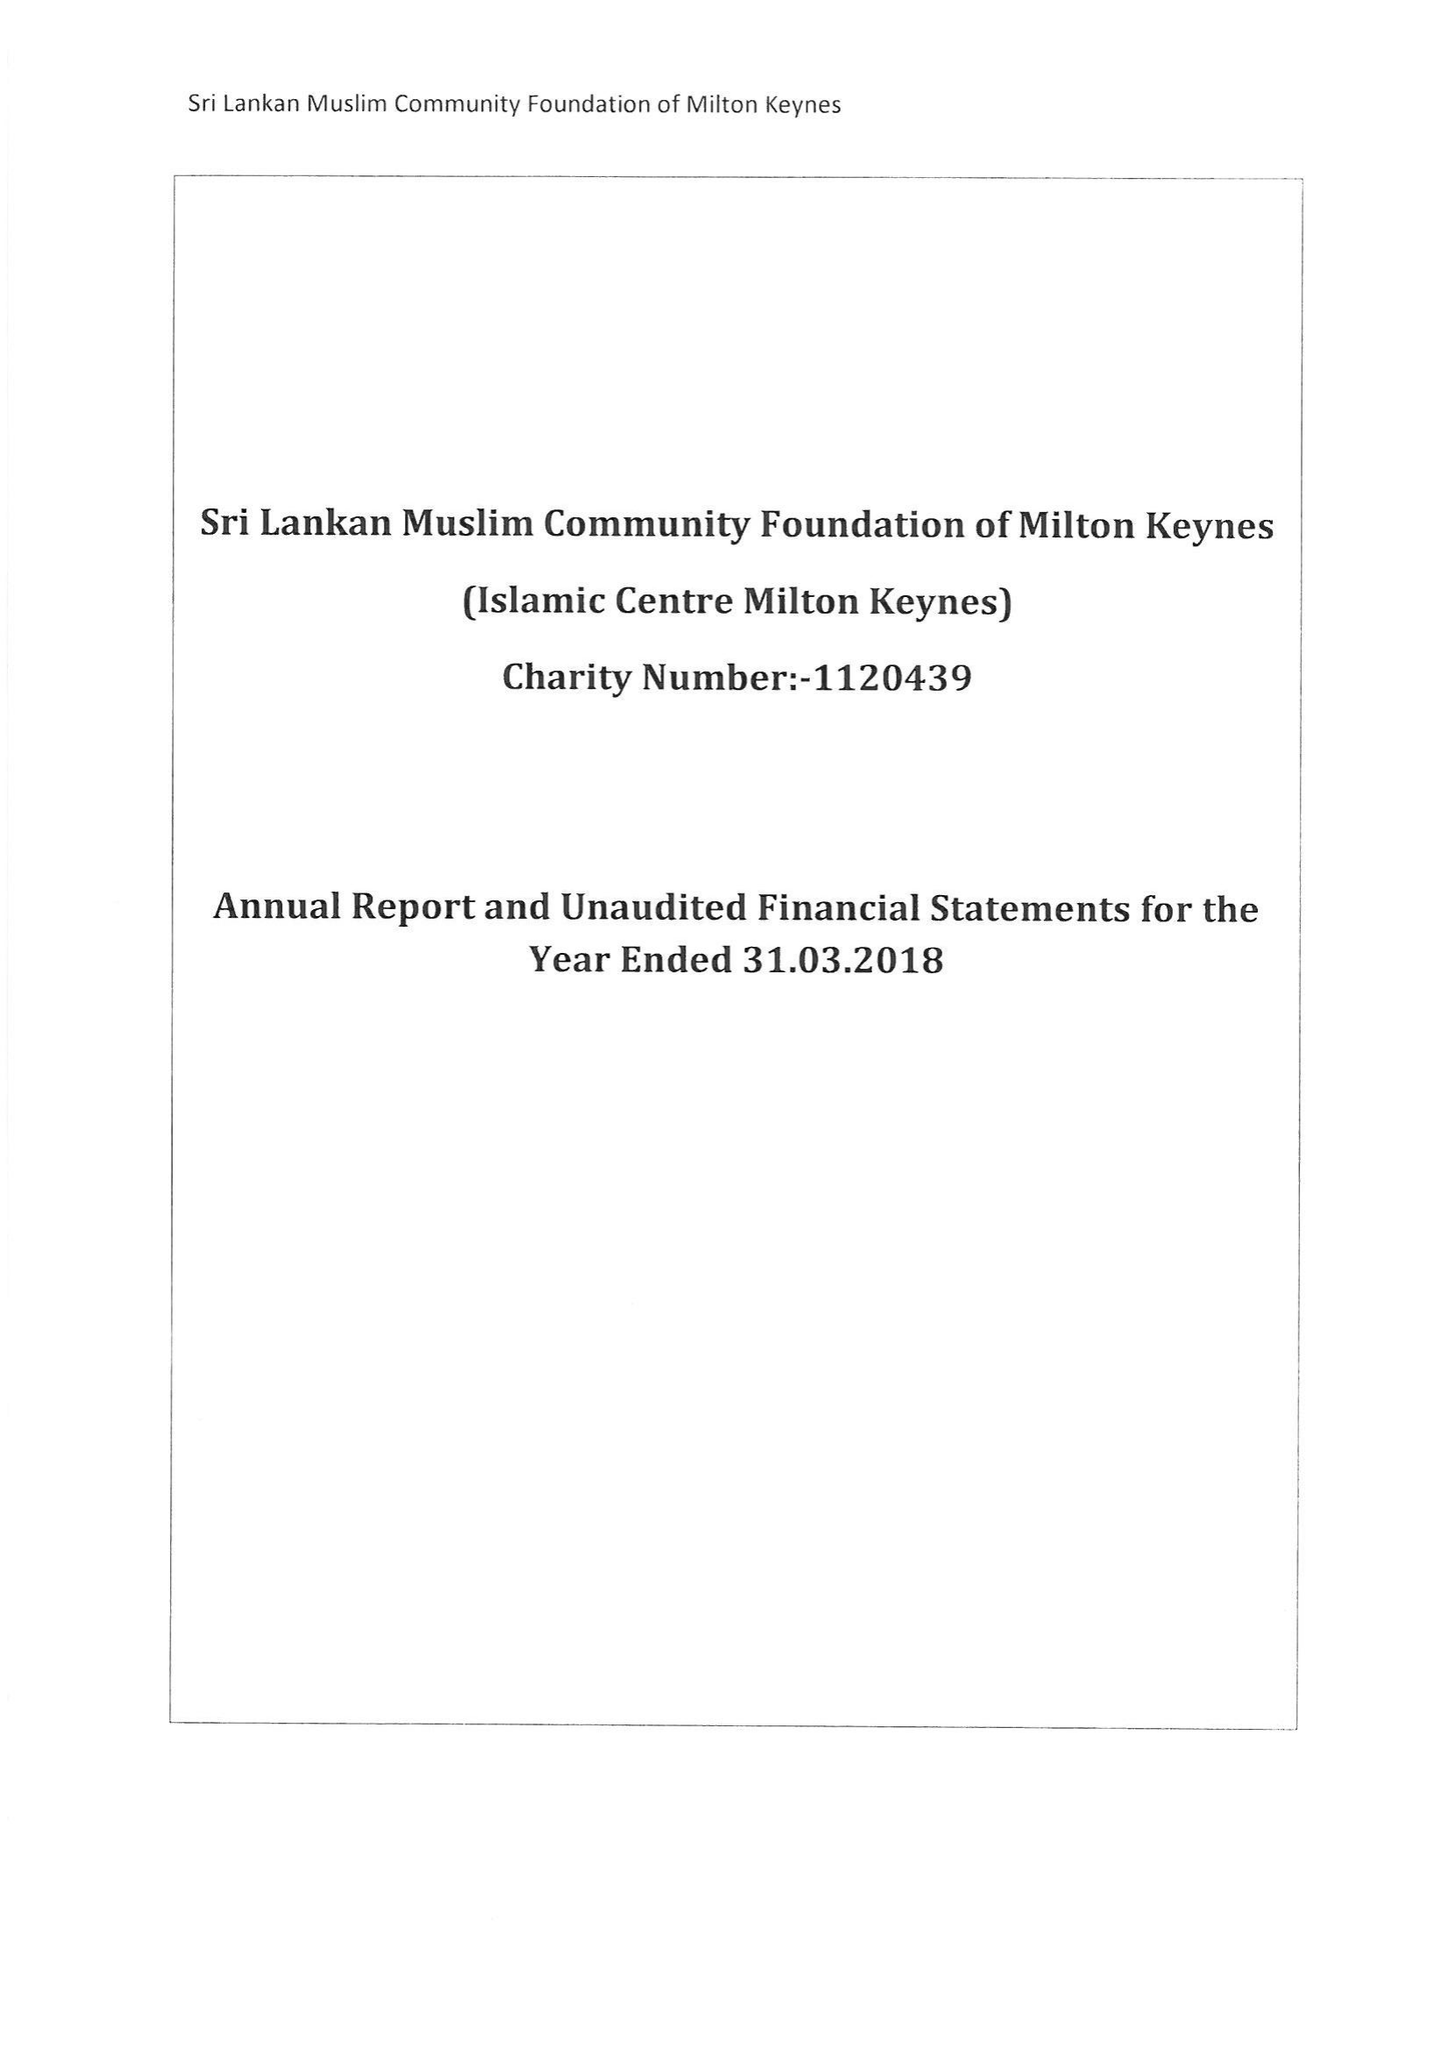What is the value for the spending_annually_in_british_pounds?
Answer the question using a single word or phrase. 100043.00 